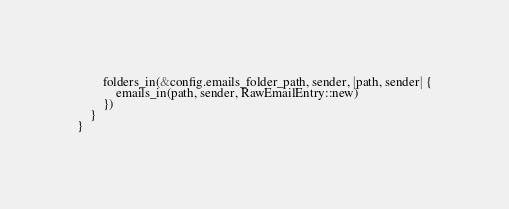<code> <loc_0><loc_0><loc_500><loc_500><_Rust_>        folders_in(&config.emails_folder_path, sender, |path, sender| {
            emails_in(path, sender, RawEmailEntry::new)
        })
    }
}
</code> 